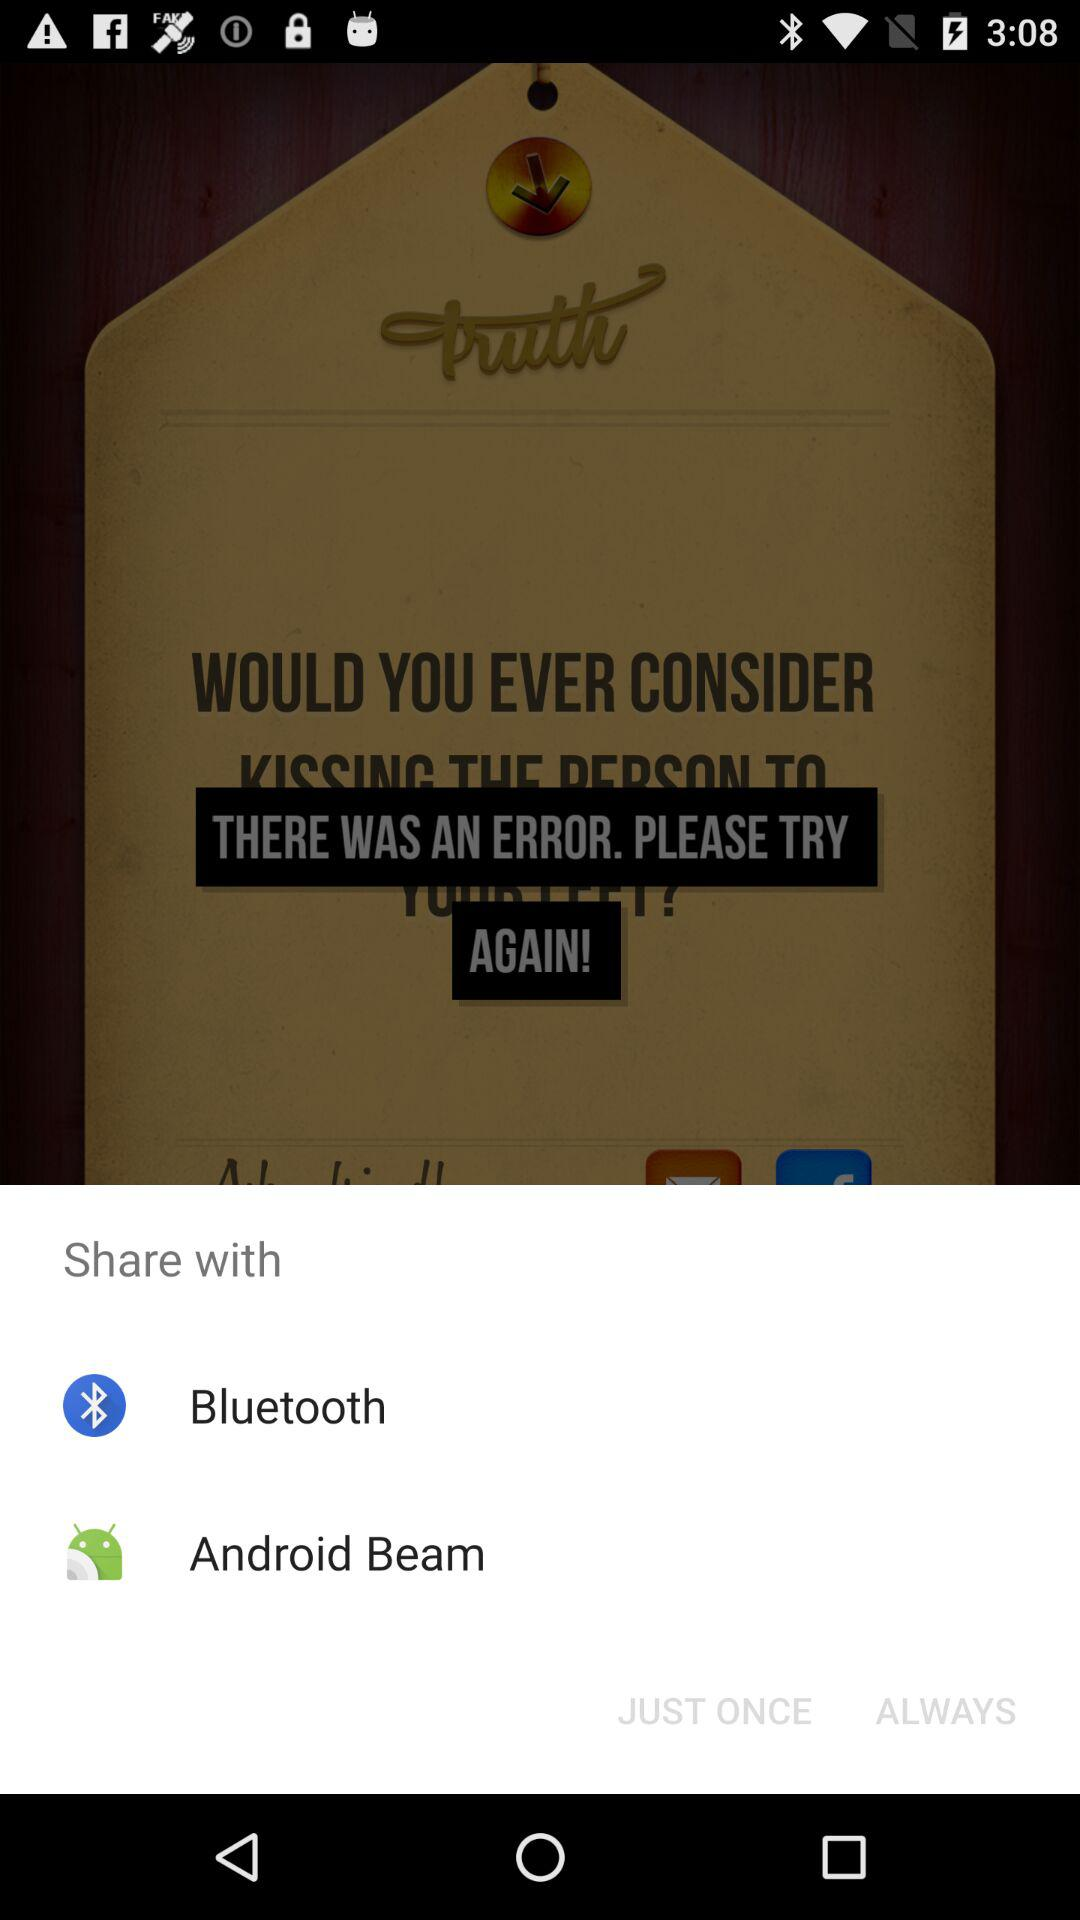How many share options are available?
Answer the question using a single word or phrase. 2 